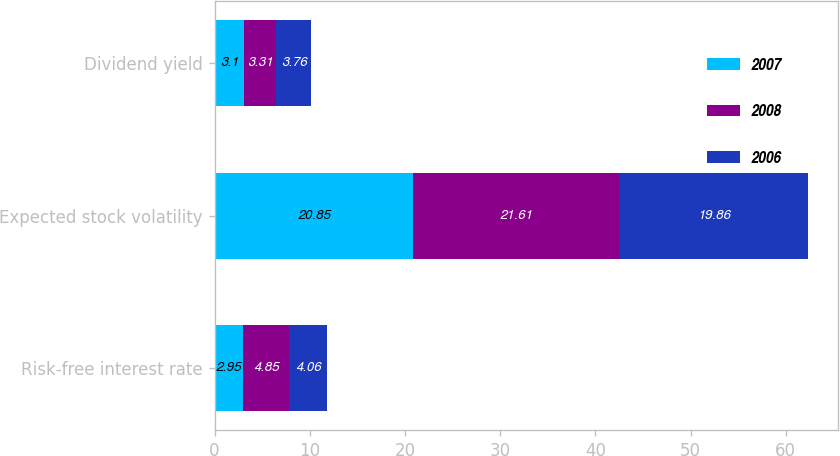<chart> <loc_0><loc_0><loc_500><loc_500><stacked_bar_chart><ecel><fcel>Risk-free interest rate<fcel>Expected stock volatility<fcel>Dividend yield<nl><fcel>2007<fcel>2.95<fcel>20.85<fcel>3.1<nl><fcel>2008<fcel>4.85<fcel>21.61<fcel>3.31<nl><fcel>2006<fcel>4.06<fcel>19.86<fcel>3.76<nl></chart> 